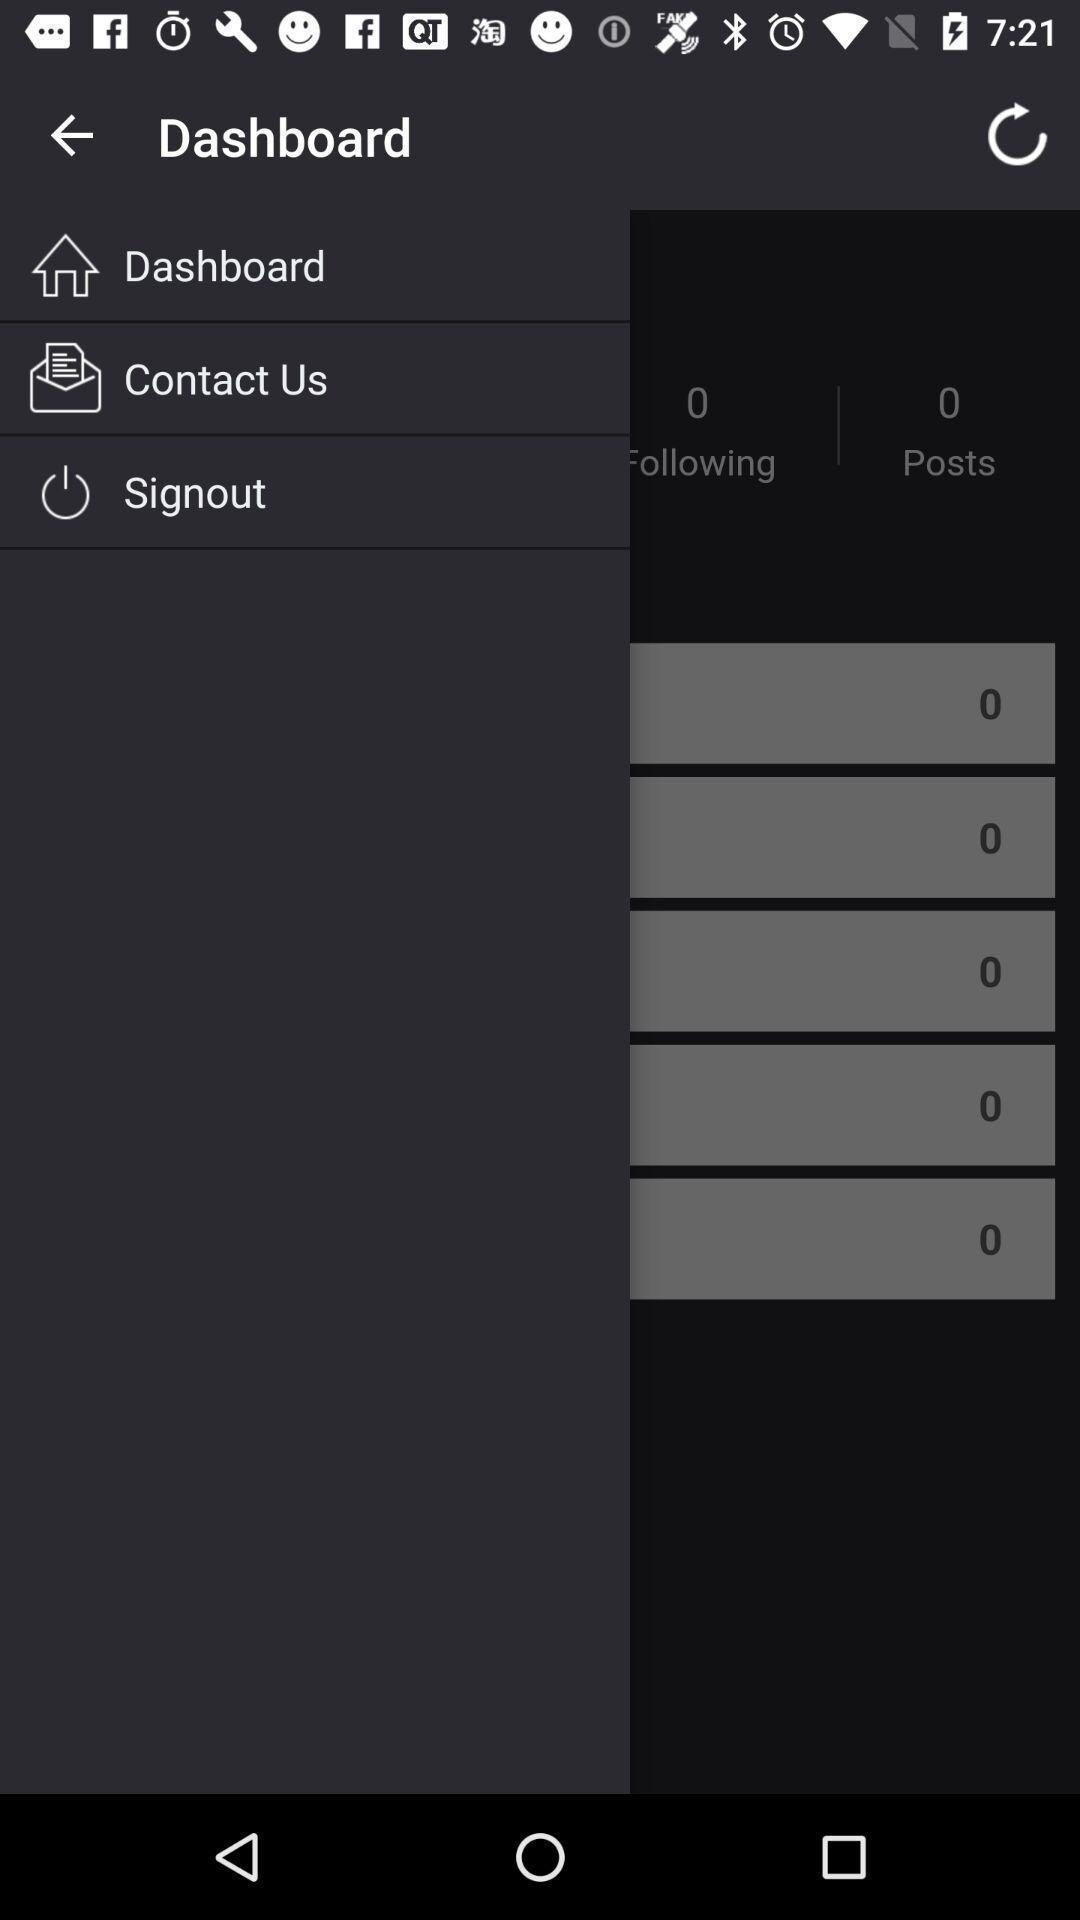Provide a textual representation of this image. Pop up showing list of numbers. 